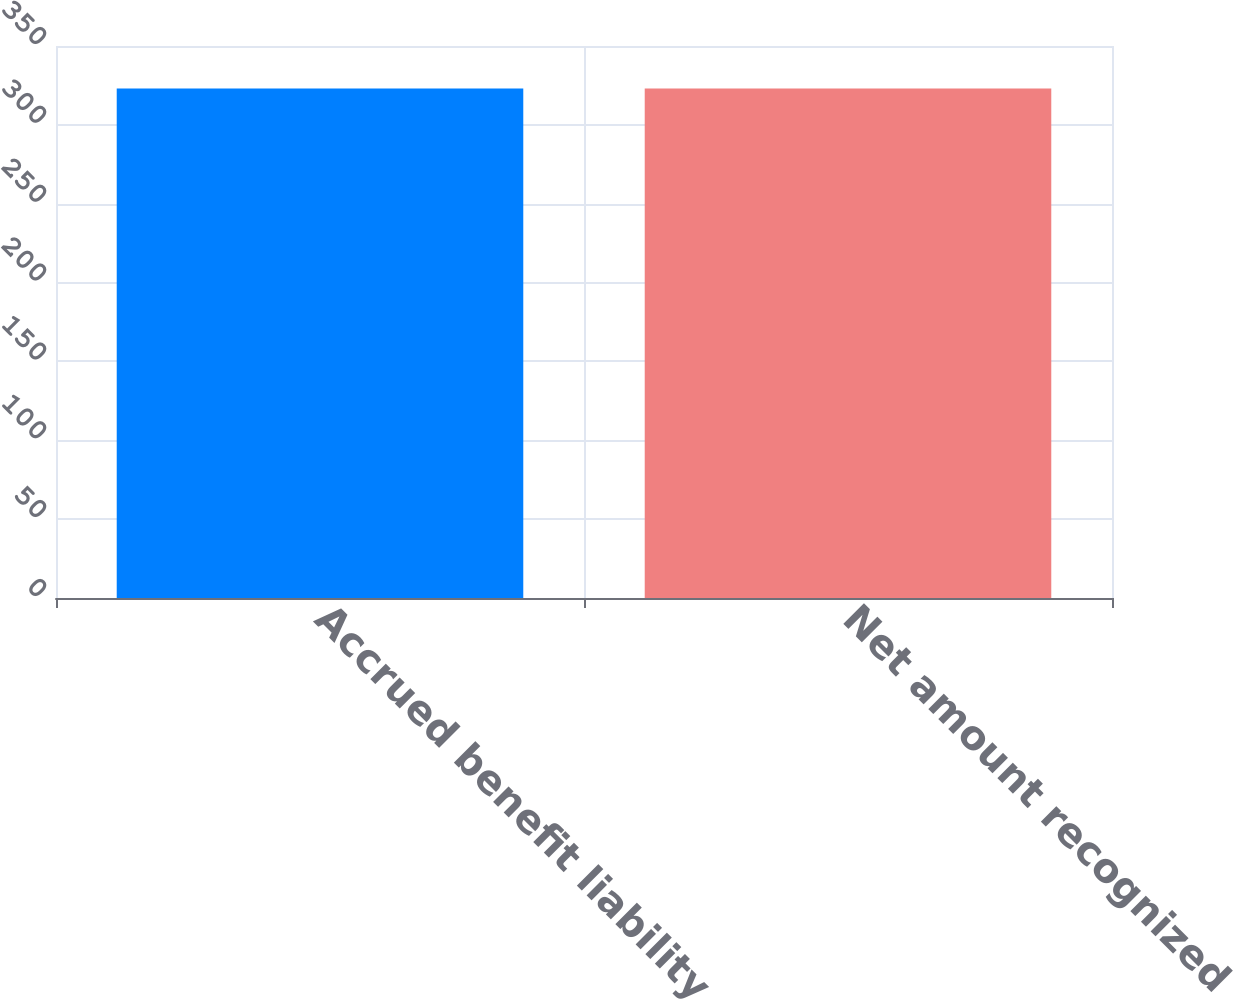Convert chart. <chart><loc_0><loc_0><loc_500><loc_500><bar_chart><fcel>Accrued benefit liability<fcel>Net amount recognized<nl><fcel>323<fcel>323.1<nl></chart> 